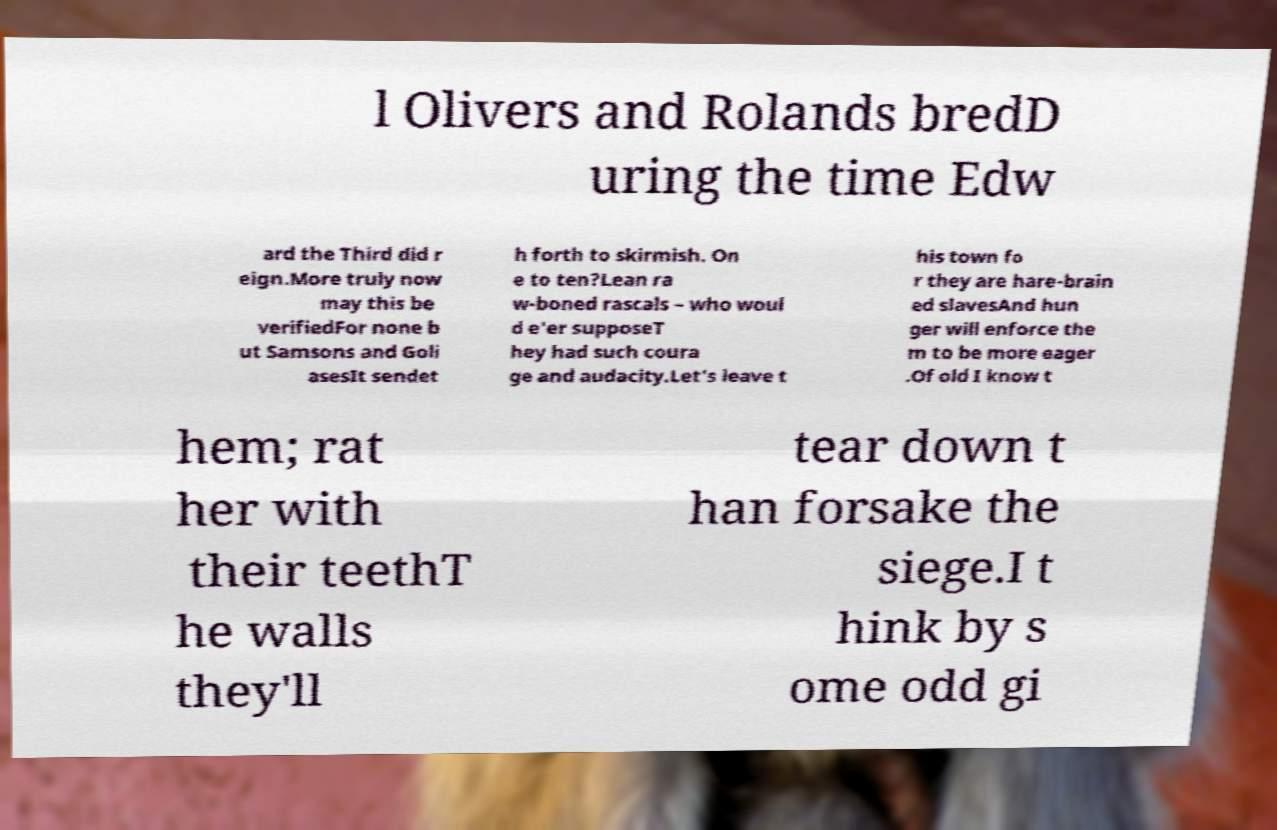Can you read and provide the text displayed in the image?This photo seems to have some interesting text. Can you extract and type it out for me? l Olivers and Rolands bredD uring the time Edw ard the Third did r eign.More truly now may this be verifiedFor none b ut Samsons and Goli asesIt sendet h forth to skirmish. On e to ten?Lean ra w-boned rascals – who woul d e'er supposeT hey had such coura ge and audacity.Let's leave t his town fo r they are hare-brain ed slavesAnd hun ger will enforce the m to be more eager .Of old I know t hem; rat her with their teethT he walls they'll tear down t han forsake the siege.I t hink by s ome odd gi 